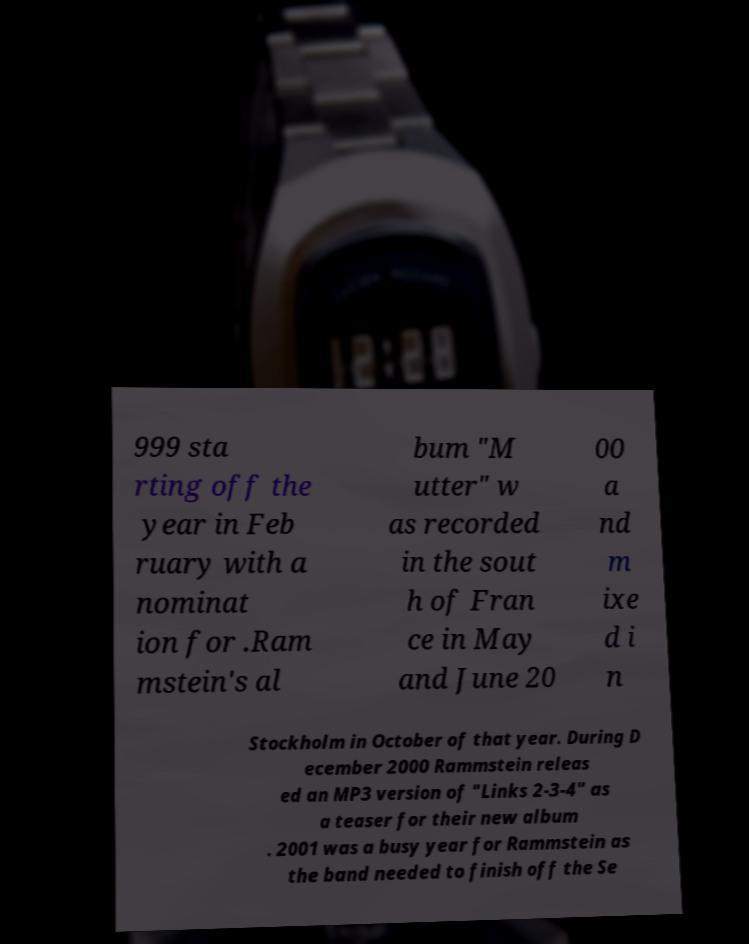Please identify and transcribe the text found in this image. 999 sta rting off the year in Feb ruary with a nominat ion for .Ram mstein's al bum "M utter" w as recorded in the sout h of Fran ce in May and June 20 00 a nd m ixe d i n Stockholm in October of that year. During D ecember 2000 Rammstein releas ed an MP3 version of "Links 2-3-4" as a teaser for their new album . 2001 was a busy year for Rammstein as the band needed to finish off the Se 